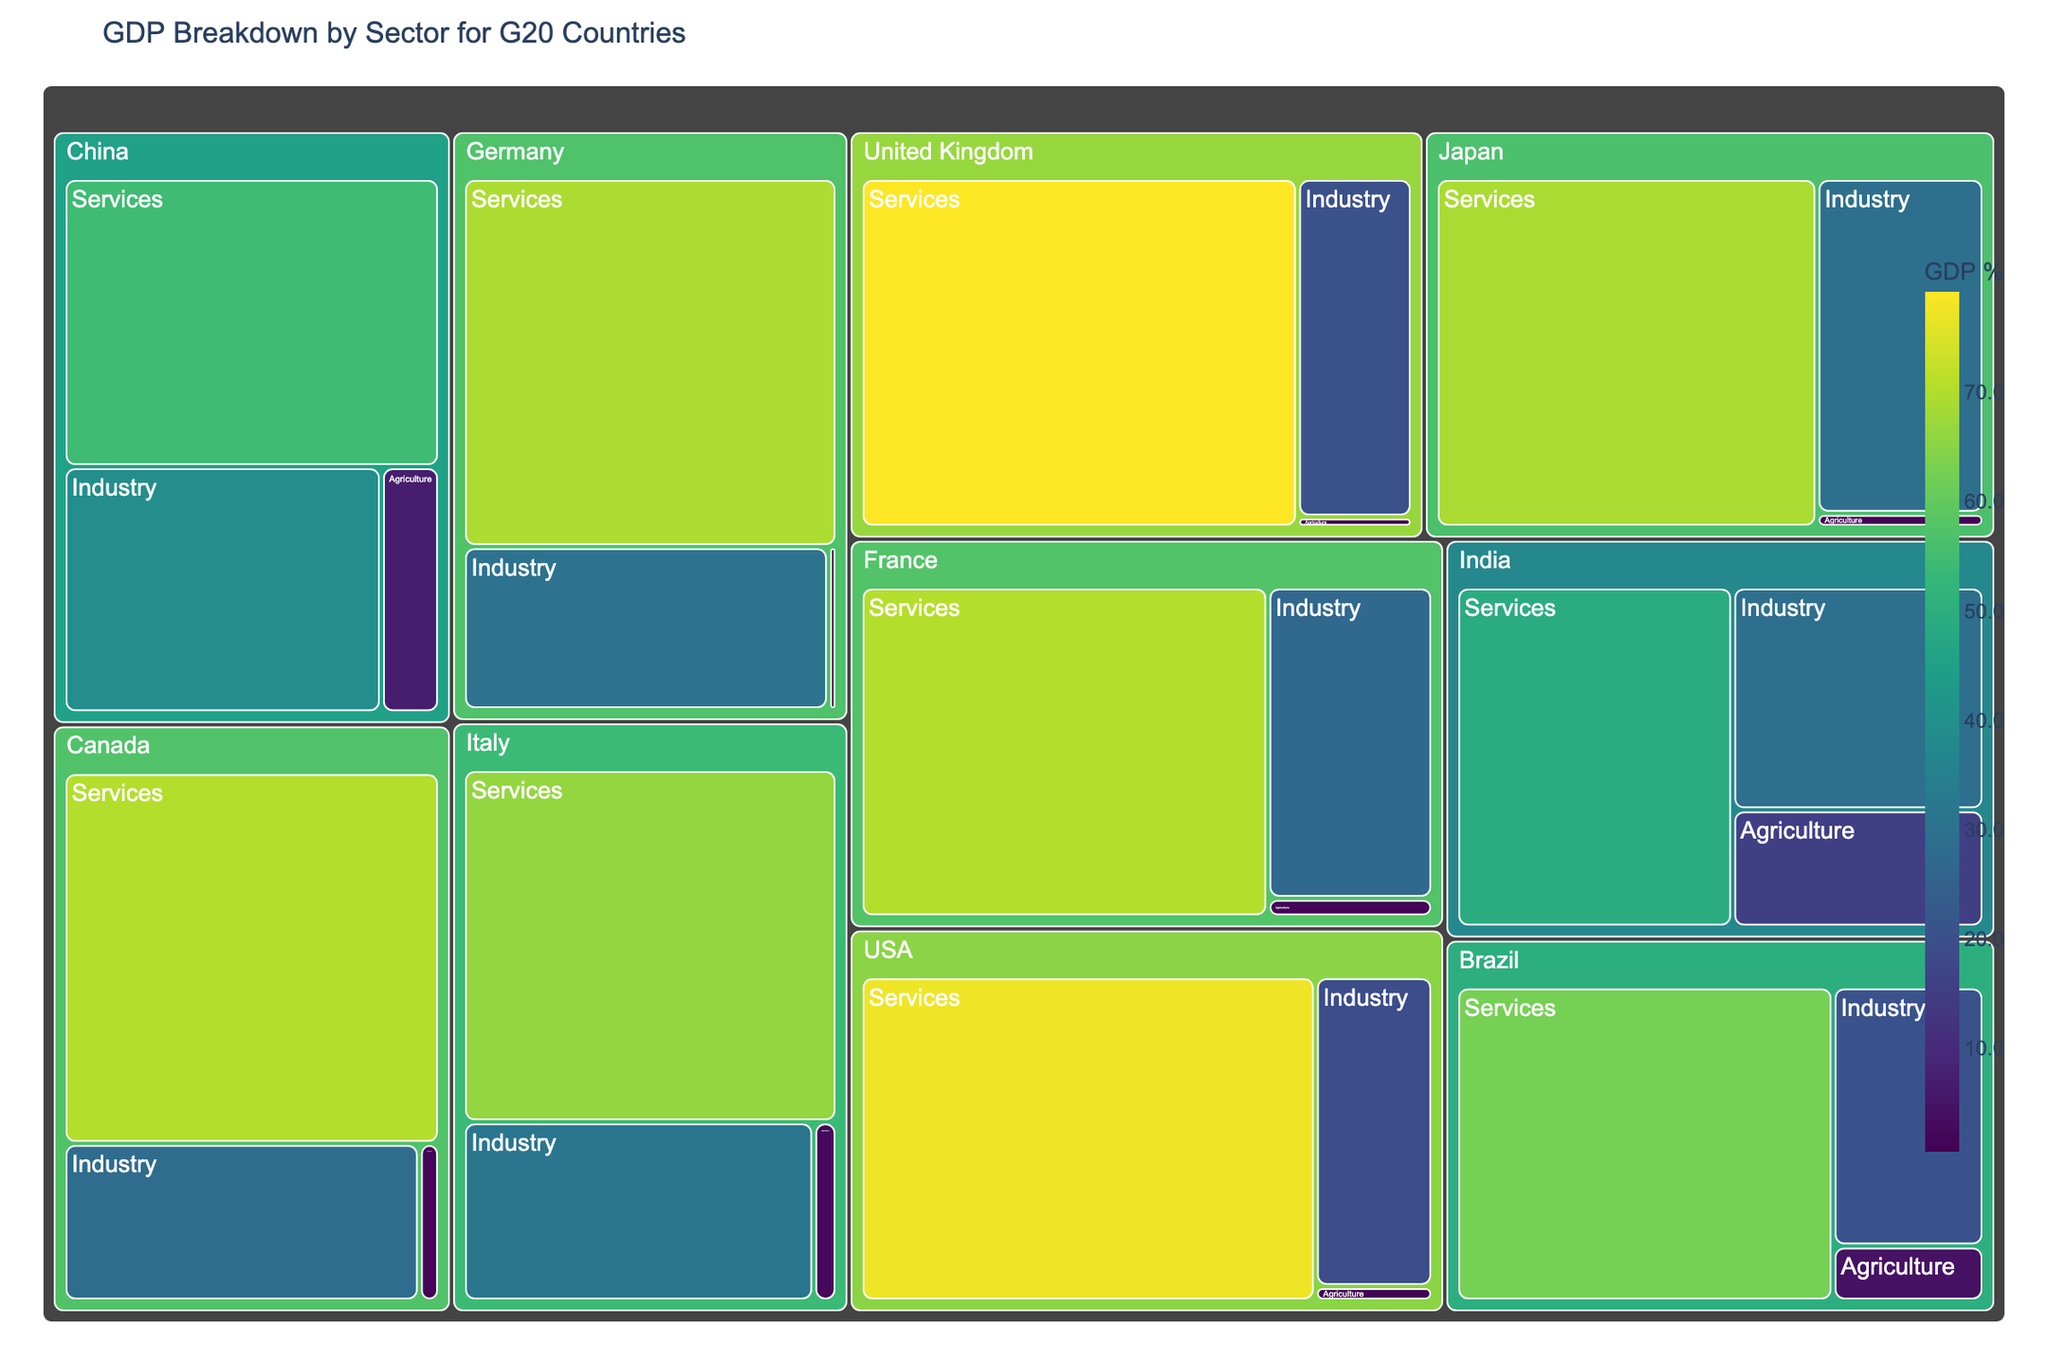What's the title of the figure? The title of the figure is usually displayed at the top and summarizes the content of the visualization. In this case, it's the string provided in the code under the title parameter in the px.treemap function.
Answer: GDP Breakdown by Sector for G20 Countries Which country has the highest percentage of GDP from the services sector? To determine this, look at the largest sector block under the "Services" partition for each country. The block size corresponds to the GDP percentage; thus, the largest services block represents the highest percentage.
Answer: United Kingdom What's the total GDP percentage from agriculture for Germany and Japan combined? Add the percentages from the Agriculture sector blocks for both Germany and Japan. These percentages are found under the "Agriculture" partition for each country. Germany has 0.7% and Japan has 1.2%. Adding them together gives 0.7 + 1.2.
Answer: 1.9% Which sector contributes the least to the GDP for Italy? Look at the smallest block under Italy's partition. The sector with the smallest block represents the least GDP percentage. For Italy, it's the Agriculture sector block.
Answer: Agriculture What's the percentage difference between the industry sectors of China and India? Subtract the percentage of the Industry sector of India from that of China. China's Industry percentage is 39.3%, and India's is 29.3%. So, 39.3 - 29.3.
Answer: 10% What is the combined GDP percentage of industry and services sectors for the USA? Add the percentages of the Industry and Services sectors for the USA. The Services sector contributes 77.4%, and the Industry sector contributes 19.1%. Thus, 77.4 + 19.1.
Answer: 96.5% How does Brazil's agriculture sector compare with France's agriculture sector? Compare the sizes of the Agriculture sector blocks under Brazil and France. Brazil's Agriculture sector has a GDP percentage of 4.4%, whereas France's is 1.6%.
Answer: Greater than Which sectors are represented in the treemap for every country? The treemap shows three sectors under each country: Services, Industry, and Agriculture. These sectors are consistent across all countries.
Answer: Services, Industry, Agriculture What is the average GDP percentage for the services sector across all countries shown? Add the percentages of the Services sector for all listed countries and divide by the number of these countries. The countries listed are USA, China, Japan, Germany, United Kingdom, France, India, Italy, Brazil, and Canada. Summing: 77.4 + 54.5 + 69.1 + 69.3 + 79.2 + 70.3 + 49.1 + 66.3 + 62.6 + 70.2 = 667. Divide by 10.
Answer: 66.7% What's the overall visual appearance of the plot? This question focuses on the customization and styling of the treemap. The plot utilizes the Viridis color scale, white text for labels, and rounded corners for blocks. Specific details like font family and size, margins, and a well-positioned color bar are part of the appearance.
Answer: Stylized with Viridis colors, white text, rounded corners 